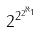<formula> <loc_0><loc_0><loc_500><loc_500>2 ^ { 2 ^ { 2 ^ { \aleph _ { 1 } } } }</formula> 